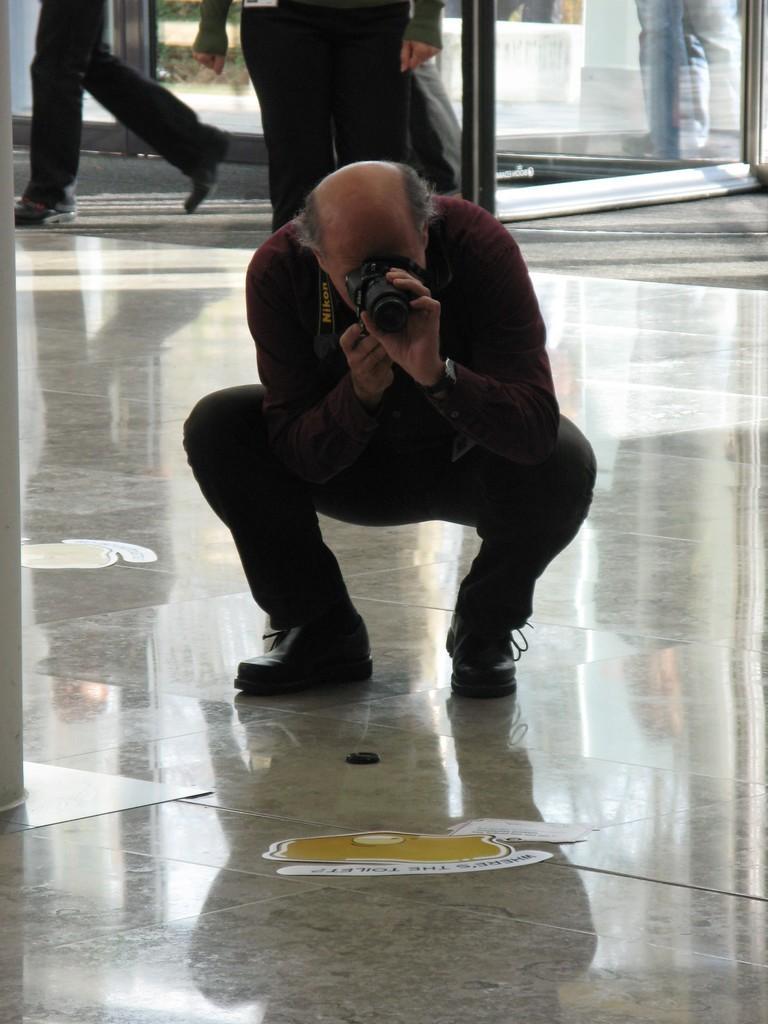In one or two sentences, can you explain what this image depicts? In the picture we can see a man standing and bending on legs and capturing a picture with a camera on the floor and in the background we can see some persons are walking and some are standing near the glass door. 